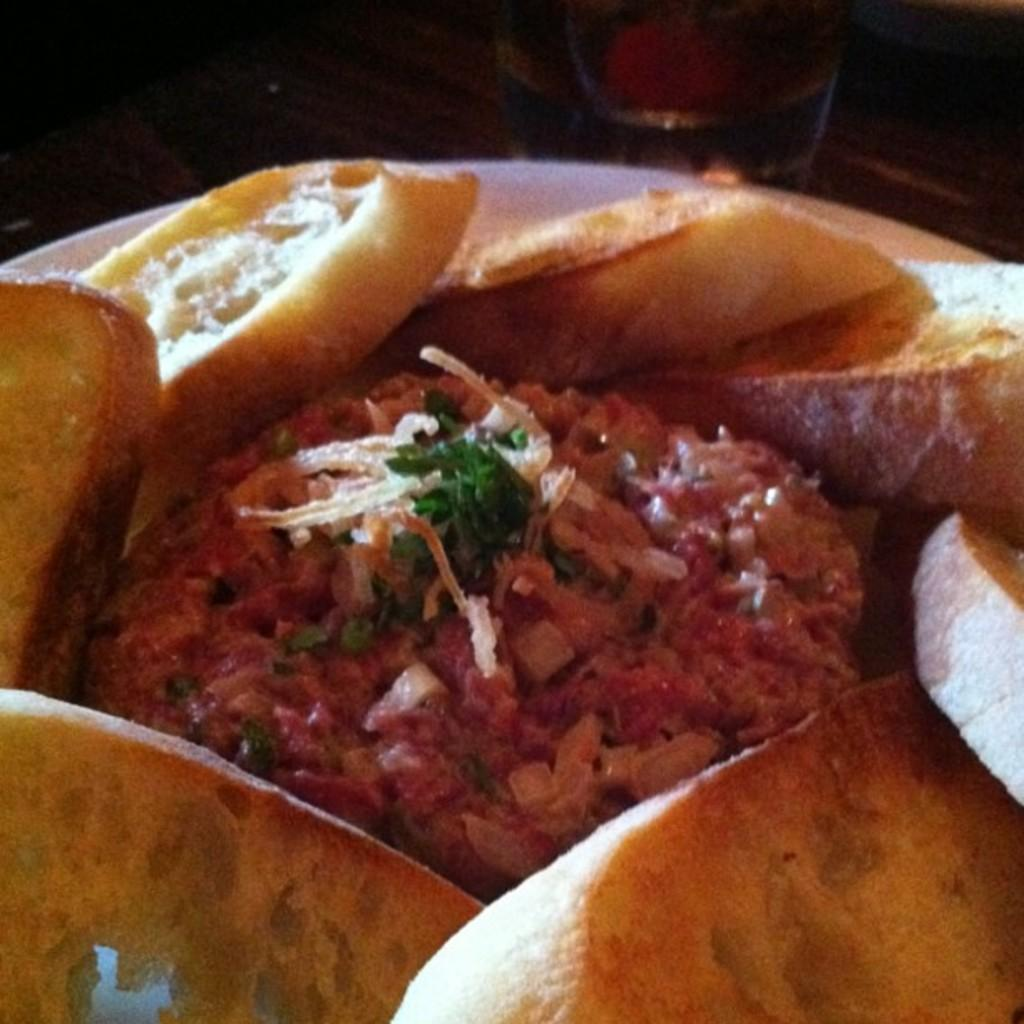What is placed on the plate in the image? There is a plate of food items in the image. What type of apparatus can be seen in the image? There is no apparatus present in the image; it features a plate of food items. How many boys are visible in the image? There are no boys visible in the image; it only shows a plate of food items. 